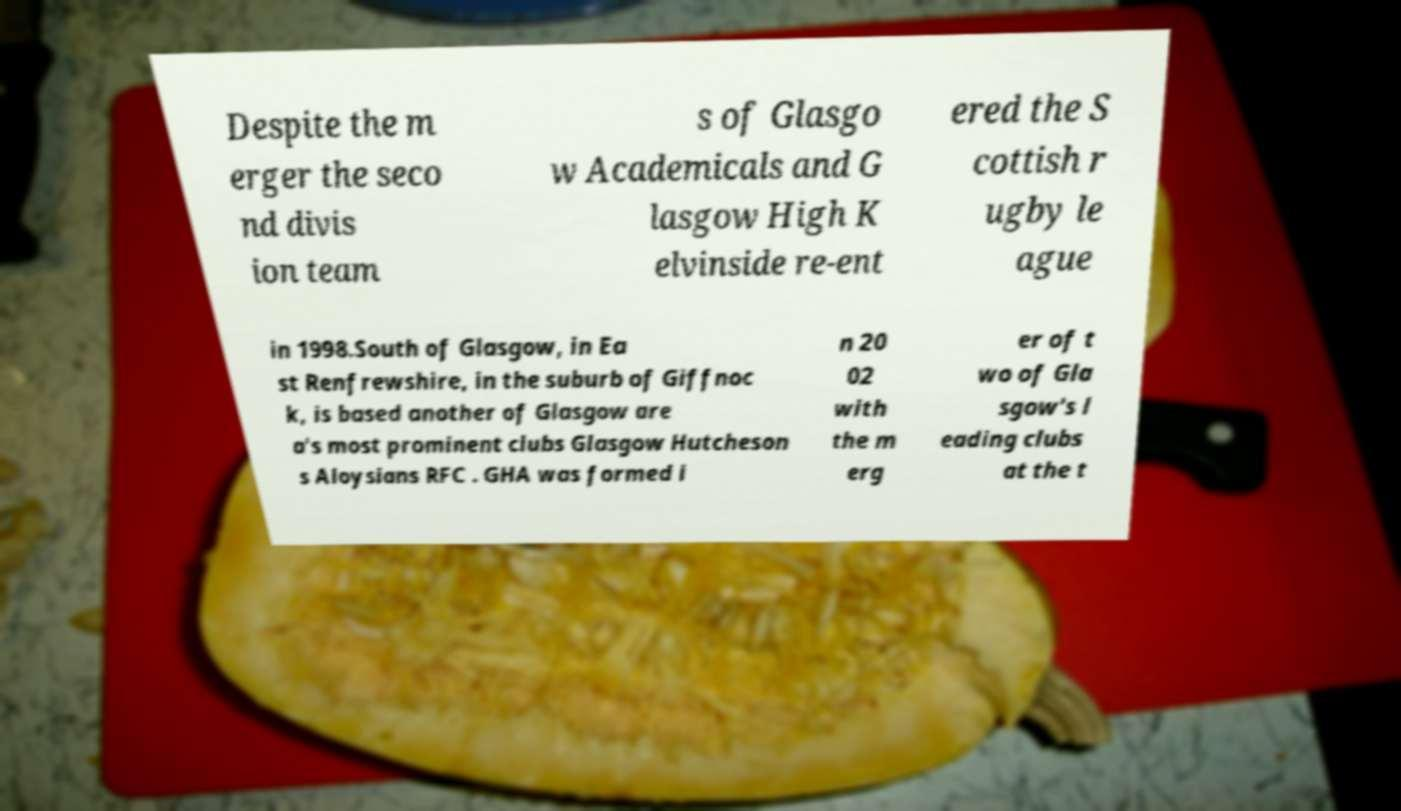Could you extract and type out the text from this image? Despite the m erger the seco nd divis ion team s of Glasgo w Academicals and G lasgow High K elvinside re-ent ered the S cottish r ugby le ague in 1998.South of Glasgow, in Ea st Renfrewshire, in the suburb of Giffnoc k, is based another of Glasgow are a's most prominent clubs Glasgow Hutcheson s Aloysians RFC . GHA was formed i n 20 02 with the m erg er of t wo of Gla sgow's l eading clubs at the t 